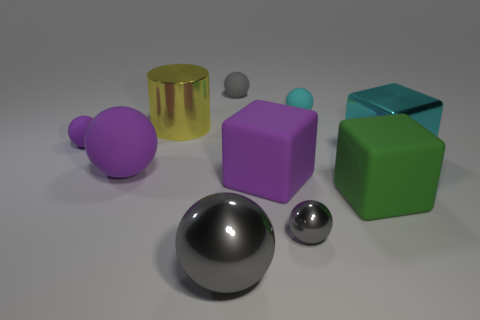Do the yellow thing and the cyan metal object have the same size?
Offer a terse response. Yes. What is the material of the big cyan object?
Make the answer very short. Metal. There is a large block that is made of the same material as the yellow object; what is its color?
Ensure brevity in your answer.  Cyan. Are the green object and the gray thing behind the small cyan ball made of the same material?
Provide a short and direct response. Yes. What number of small gray spheres have the same material as the big yellow thing?
Keep it short and to the point. 1. The large shiny object that is on the right side of the tiny cyan thing has what shape?
Provide a short and direct response. Cube. Is the material of the big ball on the left side of the yellow cylinder the same as the cyan thing in front of the cylinder?
Your answer should be very brief. No. Is there a big blue thing that has the same shape as the green object?
Give a very brief answer. No. What number of things are either rubber objects to the left of the green rubber cube or small cyan metal things?
Your answer should be very brief. 5. Is the number of tiny gray matte spheres in front of the big yellow object greater than the number of big balls that are in front of the small shiny sphere?
Offer a very short reply. No. 